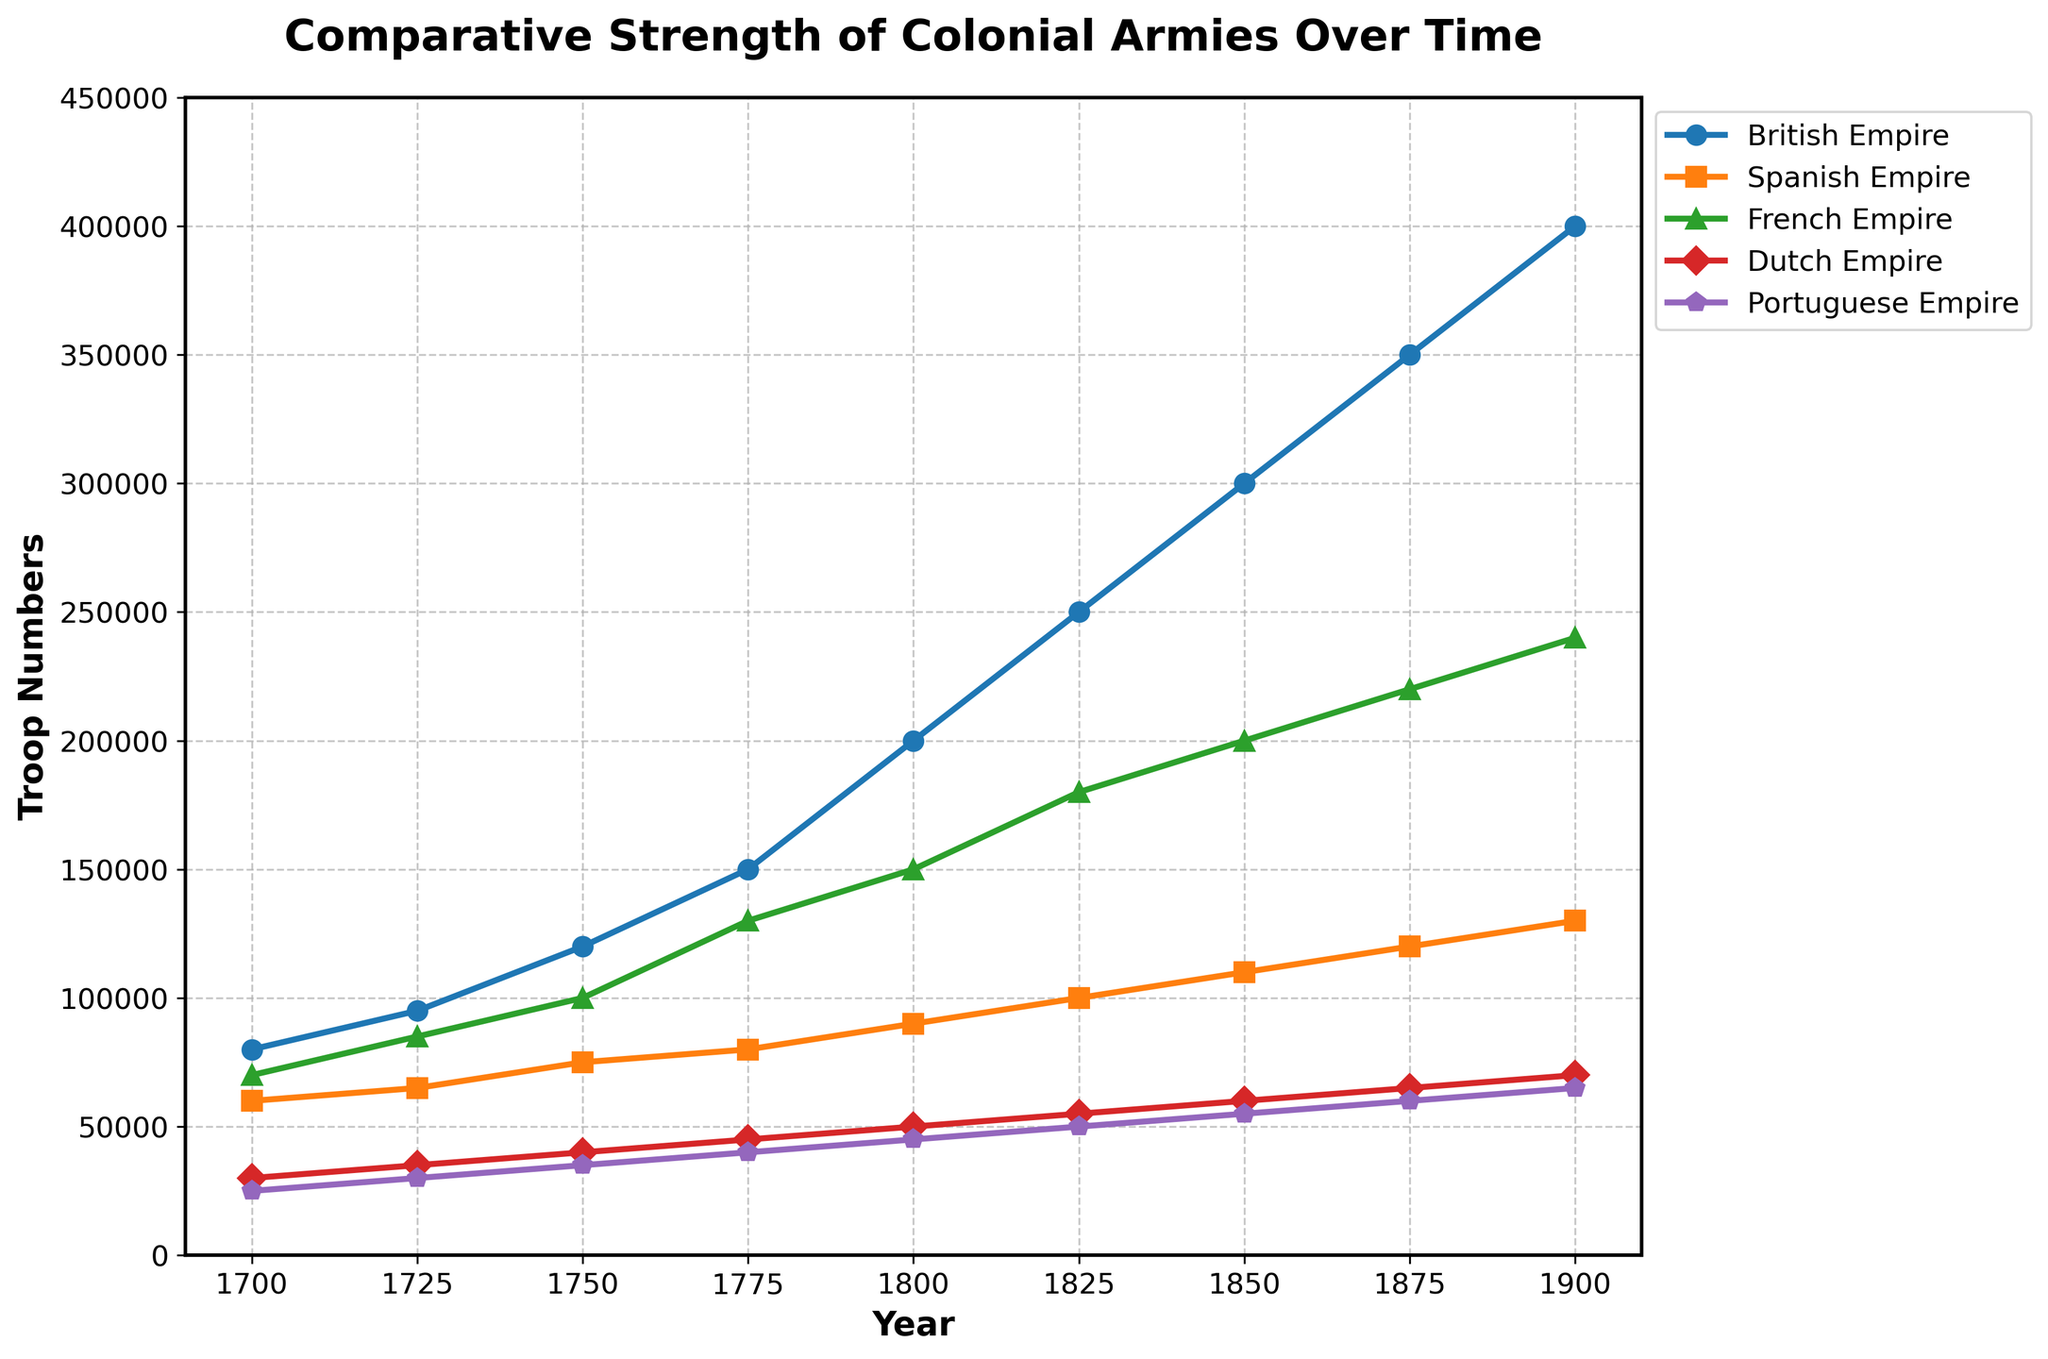What is the total number of troops for the British and French Empires in 1800? First, extract the troop numbers for the British Empire (200,000) and the French Empire (150,000) in the year 1800. Next, sum these values: 200,000 + 150,000 = 350,000.
Answer: 350,000 In which year did the Portuguese Empire have the lowest troop number, and what was the value? Scan the line for the Portuguese Empire and identify the lowest data point. This occurs in 1700, which is 25,000 troops.
Answer: 1700, 25,000 How much did the number of troops in the Dutch Empire increase from 1725 to 1900? Extract the troop numbers for the Dutch Empire in 1725 (35,000) and in 1900 (70,000). Calculate the difference: 70,000 - 35,000 = 35,000.
Answer: 35,000 Between 1825 and 1850, how much did the Spanish Empire's troop number change? Extract the troop numbers for the Spanish Empire in 1825 (100,000) and in 1850 (110,000). Calculate the difference: 110,000 - 100,000 = 10,000.
Answer: 10,000 Which empire had the highest troop number in 1900, and what was the number? Identify the data points for 1900 and compare the troop numbers. The British Empire has the highest with 400,000 troops.
Answer: British Empire, 400,000 How many years did it take for the British Empire to double its troop numbers from 1700 (80,000 troops)? Scan the data for the British Empire and look for the year when the troop number is approximately double 80,000 (160,000 troops). This occurs in 1775. Subtract 1700 from 1775: 1775 - 1700 = 75 years.
Answer: 75 years Which empire had the smallest increase in troop numbers from 1700 to 1900? Calculate the increase for each empire over this period and compare: 
- British Empire: 400,000 - 80,000 = 320,000
- Spanish Empire: 130,000 - 60,000 = 70,000
- French Empire: 240,000 - 70,000 = 170,000
- Dutch Empire: 70,000 - 30,000 = 40,000
- Portuguese Empire: 65,000 - 25,000 = 40,000
The Dutch and Portuguese Empires both have the smallest increase of 40,000.
Answer: Dutch and Portuguese Empires, 40,000 What was the average troop number of the French Empire over the recorded years? Take the French Empire's troop numbers for all years: [70,000, 85,000, 100,000, 130,000, 150,000, 180,000, 200,000, 220,000, 240,000]. Sum these values to get 1,375,000. Divide by the number of years (9): 1,375,000 / 9 ≈ 152,778.
Answer: 152,778 Which two empires had equal troop numbers in 1725? Compare the troop numbers for each empire in 1725 and identify any matches. Both the Dutch Empire and Portuguese Empire have 35,000 troops.
Answer: Dutch Empire and Portuguese Empire, 35,000 